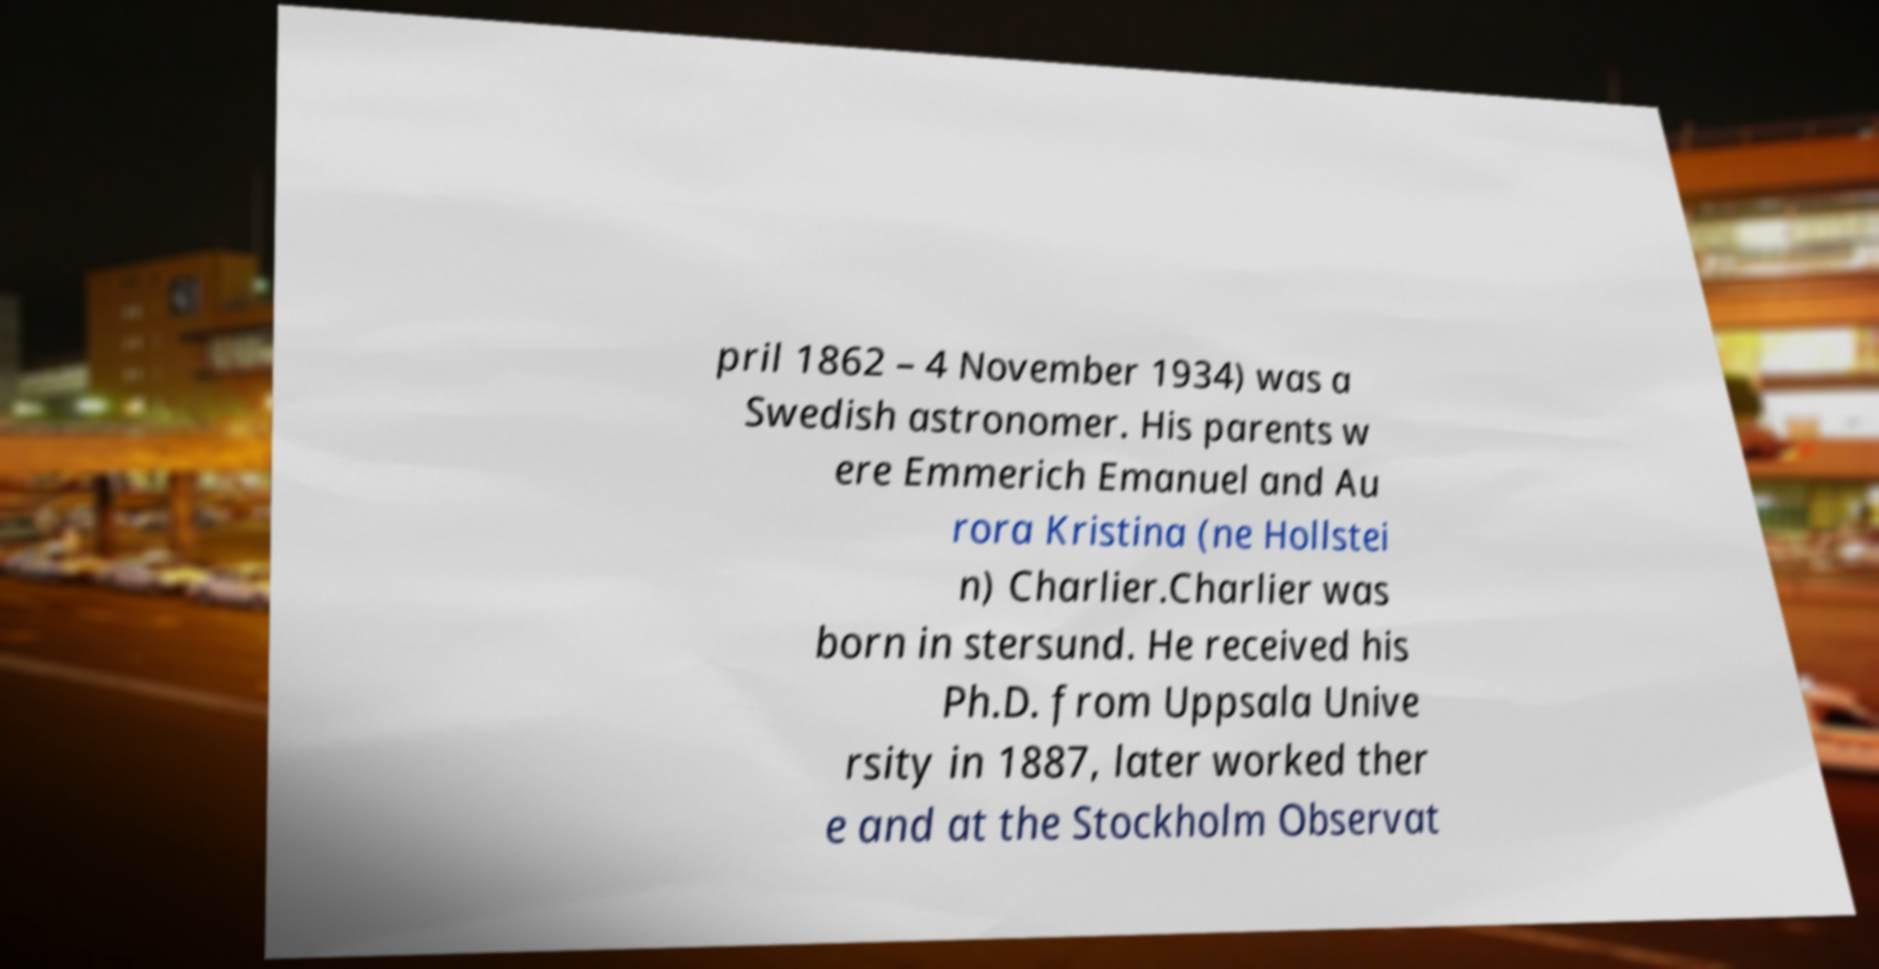Please identify and transcribe the text found in this image. pril 1862 – 4 November 1934) was a Swedish astronomer. His parents w ere Emmerich Emanuel and Au rora Kristina (ne Hollstei n) Charlier.Charlier was born in stersund. He received his Ph.D. from Uppsala Unive rsity in 1887, later worked ther e and at the Stockholm Observat 